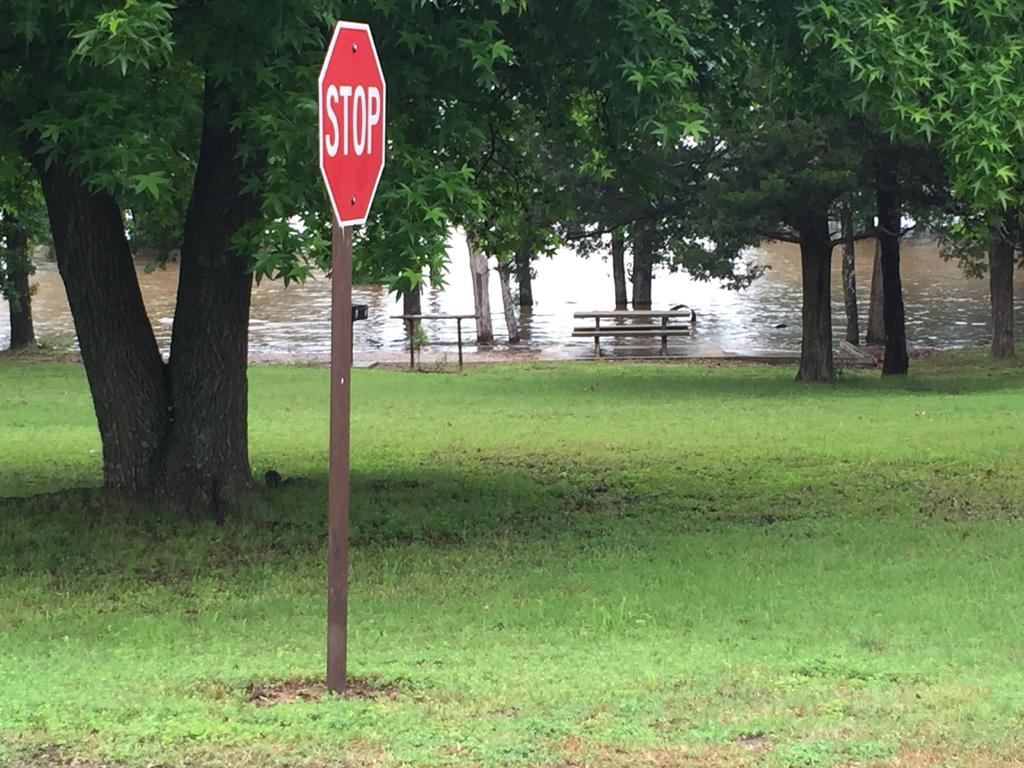What is the main object in the image? There is a stop board in the image. What type of environment surrounds the stop board? There is a lot of grass around the stop board, and trees are also present on the grass. What can be seen in the background of the image? There is a water surface visible in the background of the image. How many dimes are scattered on the grass in the image? There are no dimes present in the image. What type of birds can be seen flying over the trees in the image? There are no birds visible in the image. 